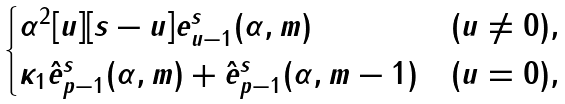<formula> <loc_0><loc_0><loc_500><loc_500>\begin{cases} \alpha ^ { 2 } [ u ] [ s - u ] { e } _ { u - 1 } ^ { s } ( \alpha , m ) & ( u \ne 0 ) , \\ \kappa _ { 1 } \hat { e } _ { p - 1 } ^ { s } ( \alpha , m ) + \hat { e } _ { p - 1 } ^ { s } ( \alpha , m - 1 ) & ( u = 0 ) , \end{cases}</formula> 